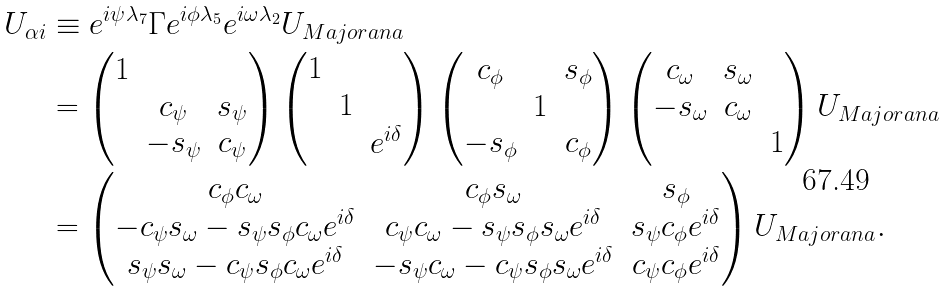<formula> <loc_0><loc_0><loc_500><loc_500>U _ { \alpha i } & \equiv e ^ { i \psi \lambda _ { 7 } } \Gamma e ^ { i \phi \lambda _ { 5 } } e ^ { i \omega \lambda _ { 2 } } U _ { M a j o r a n a } \\ & = \begin{pmatrix} 1 & & \\ & c _ { \psi } & s _ { \psi } \\ & - s _ { \psi } & c _ { \psi } \end{pmatrix} \begin{pmatrix} 1 & & \\ & 1 & \\ & & e ^ { i \delta } \end{pmatrix} \begin{pmatrix} c _ { \phi } & & s _ { \phi } \\ & 1 & \\ - s _ { \phi } & & c _ { \phi } \end{pmatrix} \begin{pmatrix} c _ { \omega } & s _ { \omega } & \\ - s _ { \omega } & c _ { \omega } & \\ & & 1 \end{pmatrix} U _ { M a j o r a n a } \\ & = \begin{pmatrix} c _ { \phi } c _ { \omega } & c _ { \phi } s _ { \omega } & s _ { \phi } \\ - c _ { \psi } s _ { \omega } - s _ { \psi } s _ { \phi } c _ { \omega } e ^ { i \delta } & c _ { \psi } c _ { \omega } - s _ { \psi } s _ { \phi } s _ { \omega } e ^ { i \delta } & s _ { \psi } c _ { \phi } e ^ { i \delta } \\ s _ { \psi } s _ { \omega } - c _ { \psi } s _ { \phi } c _ { \omega } e ^ { i \delta } & - s _ { \psi } c _ { \omega } - c _ { \psi } s _ { \phi } s _ { \omega } e ^ { i \delta } & c _ { \psi } c _ { \phi } e ^ { i \delta } \end{pmatrix} U _ { M a j o r a n a } .</formula> 